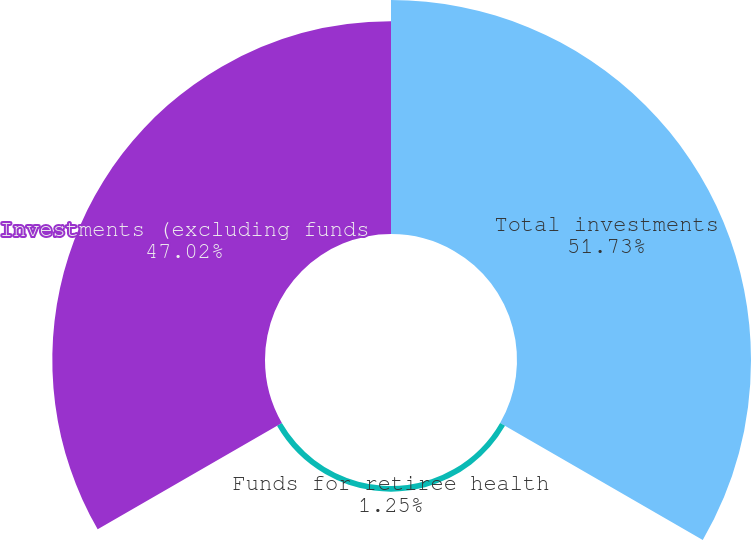Convert chart to OTSL. <chart><loc_0><loc_0><loc_500><loc_500><pie_chart><fcel>Total investments<fcel>Funds for retiree health<fcel>Investments (excluding funds<nl><fcel>51.73%<fcel>1.25%<fcel>47.02%<nl></chart> 